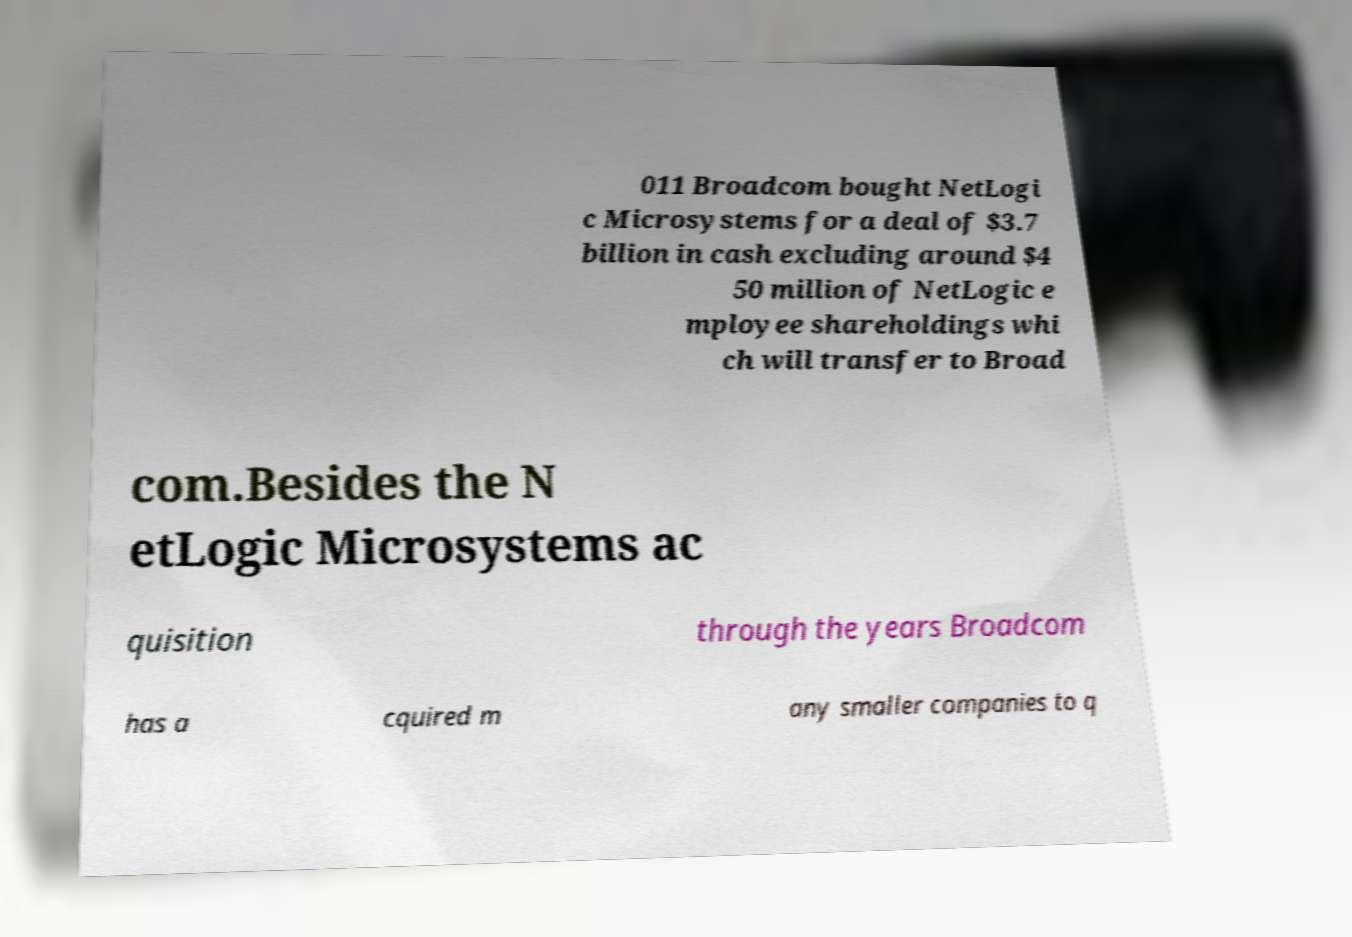Please identify and transcribe the text found in this image. 011 Broadcom bought NetLogi c Microsystems for a deal of $3.7 billion in cash excluding around $4 50 million of NetLogic e mployee shareholdings whi ch will transfer to Broad com.Besides the N etLogic Microsystems ac quisition through the years Broadcom has a cquired m any smaller companies to q 